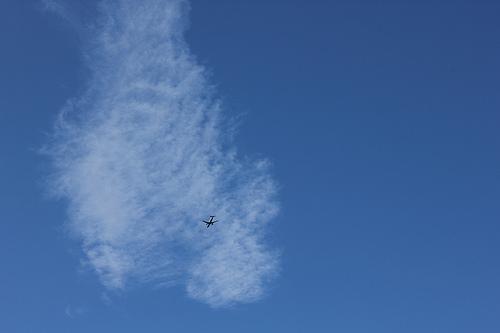How many planes are there?
Give a very brief answer. 1. 